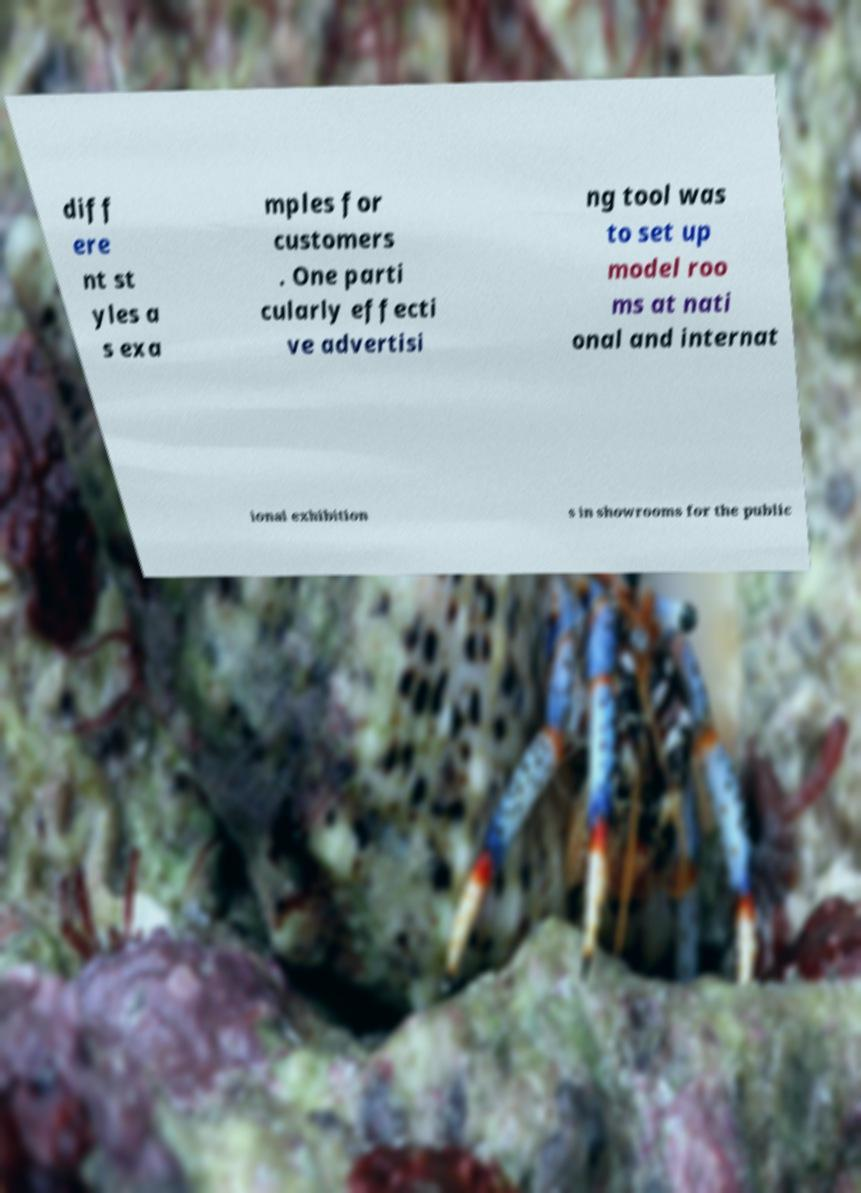I need the written content from this picture converted into text. Can you do that? diff ere nt st yles a s exa mples for customers . One parti cularly effecti ve advertisi ng tool was to set up model roo ms at nati onal and internat ional exhibition s in showrooms for the public 